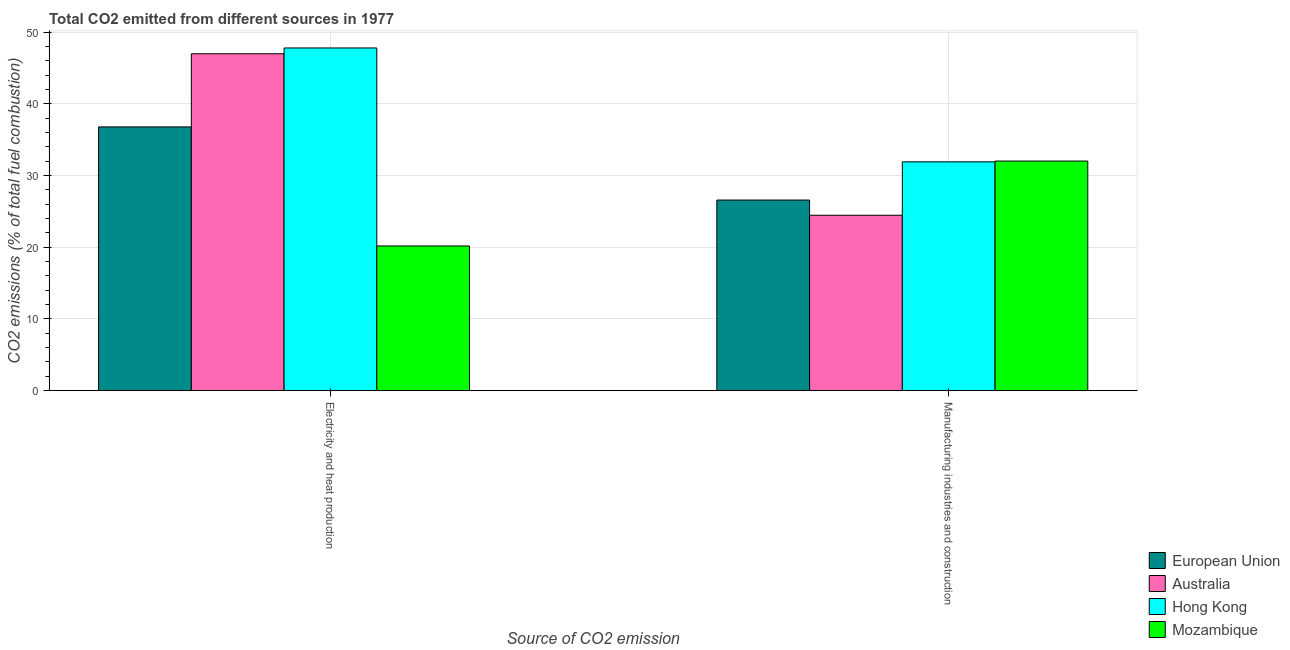How many different coloured bars are there?
Make the answer very short. 4. How many groups of bars are there?
Your answer should be compact. 2. Are the number of bars per tick equal to the number of legend labels?
Make the answer very short. Yes. Are the number of bars on each tick of the X-axis equal?
Your response must be concise. Yes. How many bars are there on the 1st tick from the left?
Offer a very short reply. 4. How many bars are there on the 1st tick from the right?
Your answer should be very brief. 4. What is the label of the 1st group of bars from the left?
Provide a short and direct response. Electricity and heat production. What is the co2 emissions due to manufacturing industries in Mozambique?
Your answer should be compact. 32.02. Across all countries, what is the maximum co2 emissions due to electricity and heat production?
Make the answer very short. 47.79. Across all countries, what is the minimum co2 emissions due to electricity and heat production?
Your answer should be compact. 20.18. In which country was the co2 emissions due to electricity and heat production maximum?
Make the answer very short. Hong Kong. What is the total co2 emissions due to electricity and heat production in the graph?
Your answer should be very brief. 151.73. What is the difference between the co2 emissions due to manufacturing industries in Mozambique and that in Australia?
Your answer should be very brief. 7.56. What is the difference between the co2 emissions due to manufacturing industries in Hong Kong and the co2 emissions due to electricity and heat production in Australia?
Provide a short and direct response. -15.08. What is the average co2 emissions due to manufacturing industries per country?
Give a very brief answer. 28.74. What is the difference between the co2 emissions due to electricity and heat production and co2 emissions due to manufacturing industries in Hong Kong?
Make the answer very short. 15.88. In how many countries, is the co2 emissions due to manufacturing industries greater than 26 %?
Offer a very short reply. 3. What is the ratio of the co2 emissions due to electricity and heat production in Mozambique to that in European Union?
Ensure brevity in your answer.  0.55. What does the 1st bar from the right in Manufacturing industries and construction represents?
Provide a succinct answer. Mozambique. How many bars are there?
Your answer should be very brief. 8. Does the graph contain grids?
Provide a succinct answer. Yes. How are the legend labels stacked?
Offer a terse response. Vertical. What is the title of the graph?
Provide a short and direct response. Total CO2 emitted from different sources in 1977. What is the label or title of the X-axis?
Your response must be concise. Source of CO2 emission. What is the label or title of the Y-axis?
Your answer should be compact. CO2 emissions (% of total fuel combustion). What is the CO2 emissions (% of total fuel combustion) in European Union in Electricity and heat production?
Offer a terse response. 36.78. What is the CO2 emissions (% of total fuel combustion) in Australia in Electricity and heat production?
Provide a short and direct response. 46.98. What is the CO2 emissions (% of total fuel combustion) in Hong Kong in Electricity and heat production?
Provide a short and direct response. 47.79. What is the CO2 emissions (% of total fuel combustion) in Mozambique in Electricity and heat production?
Give a very brief answer. 20.18. What is the CO2 emissions (% of total fuel combustion) of European Union in Manufacturing industries and construction?
Your response must be concise. 26.58. What is the CO2 emissions (% of total fuel combustion) in Australia in Manufacturing industries and construction?
Your response must be concise. 24.46. What is the CO2 emissions (% of total fuel combustion) in Hong Kong in Manufacturing industries and construction?
Provide a succinct answer. 31.91. What is the CO2 emissions (% of total fuel combustion) in Mozambique in Manufacturing industries and construction?
Your answer should be compact. 32.02. Across all Source of CO2 emission, what is the maximum CO2 emissions (% of total fuel combustion) of European Union?
Provide a short and direct response. 36.78. Across all Source of CO2 emission, what is the maximum CO2 emissions (% of total fuel combustion) of Australia?
Offer a terse response. 46.98. Across all Source of CO2 emission, what is the maximum CO2 emissions (% of total fuel combustion) of Hong Kong?
Provide a succinct answer. 47.79. Across all Source of CO2 emission, what is the maximum CO2 emissions (% of total fuel combustion) in Mozambique?
Give a very brief answer. 32.02. Across all Source of CO2 emission, what is the minimum CO2 emissions (% of total fuel combustion) in European Union?
Provide a short and direct response. 26.58. Across all Source of CO2 emission, what is the minimum CO2 emissions (% of total fuel combustion) in Australia?
Offer a very short reply. 24.46. Across all Source of CO2 emission, what is the minimum CO2 emissions (% of total fuel combustion) in Hong Kong?
Offer a very short reply. 31.91. Across all Source of CO2 emission, what is the minimum CO2 emissions (% of total fuel combustion) of Mozambique?
Ensure brevity in your answer.  20.18. What is the total CO2 emissions (% of total fuel combustion) of European Union in the graph?
Your response must be concise. 63.36. What is the total CO2 emissions (% of total fuel combustion) of Australia in the graph?
Ensure brevity in your answer.  71.44. What is the total CO2 emissions (% of total fuel combustion) of Hong Kong in the graph?
Your answer should be compact. 79.7. What is the total CO2 emissions (% of total fuel combustion) in Mozambique in the graph?
Your answer should be very brief. 52.19. What is the difference between the CO2 emissions (% of total fuel combustion) of European Union in Electricity and heat production and that in Manufacturing industries and construction?
Offer a terse response. 10.2. What is the difference between the CO2 emissions (% of total fuel combustion) in Australia in Electricity and heat production and that in Manufacturing industries and construction?
Make the answer very short. 22.52. What is the difference between the CO2 emissions (% of total fuel combustion) in Hong Kong in Electricity and heat production and that in Manufacturing industries and construction?
Keep it short and to the point. 15.88. What is the difference between the CO2 emissions (% of total fuel combustion) of Mozambique in Electricity and heat production and that in Manufacturing industries and construction?
Provide a succinct answer. -11.84. What is the difference between the CO2 emissions (% of total fuel combustion) of European Union in Electricity and heat production and the CO2 emissions (% of total fuel combustion) of Australia in Manufacturing industries and construction?
Provide a short and direct response. 12.32. What is the difference between the CO2 emissions (% of total fuel combustion) in European Union in Electricity and heat production and the CO2 emissions (% of total fuel combustion) in Hong Kong in Manufacturing industries and construction?
Ensure brevity in your answer.  4.87. What is the difference between the CO2 emissions (% of total fuel combustion) in European Union in Electricity and heat production and the CO2 emissions (% of total fuel combustion) in Mozambique in Manufacturing industries and construction?
Ensure brevity in your answer.  4.76. What is the difference between the CO2 emissions (% of total fuel combustion) in Australia in Electricity and heat production and the CO2 emissions (% of total fuel combustion) in Hong Kong in Manufacturing industries and construction?
Offer a very short reply. 15.08. What is the difference between the CO2 emissions (% of total fuel combustion) in Australia in Electricity and heat production and the CO2 emissions (% of total fuel combustion) in Mozambique in Manufacturing industries and construction?
Provide a succinct answer. 14.97. What is the difference between the CO2 emissions (% of total fuel combustion) in Hong Kong in Electricity and heat production and the CO2 emissions (% of total fuel combustion) in Mozambique in Manufacturing industries and construction?
Ensure brevity in your answer.  15.77. What is the average CO2 emissions (% of total fuel combustion) of European Union per Source of CO2 emission?
Provide a succinct answer. 31.68. What is the average CO2 emissions (% of total fuel combustion) in Australia per Source of CO2 emission?
Ensure brevity in your answer.  35.72. What is the average CO2 emissions (% of total fuel combustion) of Hong Kong per Source of CO2 emission?
Your answer should be very brief. 39.85. What is the average CO2 emissions (% of total fuel combustion) in Mozambique per Source of CO2 emission?
Provide a succinct answer. 26.1. What is the difference between the CO2 emissions (% of total fuel combustion) in European Union and CO2 emissions (% of total fuel combustion) in Australia in Electricity and heat production?
Ensure brevity in your answer.  -10.2. What is the difference between the CO2 emissions (% of total fuel combustion) of European Union and CO2 emissions (% of total fuel combustion) of Hong Kong in Electricity and heat production?
Offer a very short reply. -11.01. What is the difference between the CO2 emissions (% of total fuel combustion) of European Union and CO2 emissions (% of total fuel combustion) of Mozambique in Electricity and heat production?
Your response must be concise. 16.6. What is the difference between the CO2 emissions (% of total fuel combustion) in Australia and CO2 emissions (% of total fuel combustion) in Hong Kong in Electricity and heat production?
Ensure brevity in your answer.  -0.81. What is the difference between the CO2 emissions (% of total fuel combustion) of Australia and CO2 emissions (% of total fuel combustion) of Mozambique in Electricity and heat production?
Provide a short and direct response. 26.81. What is the difference between the CO2 emissions (% of total fuel combustion) of Hong Kong and CO2 emissions (% of total fuel combustion) of Mozambique in Electricity and heat production?
Your response must be concise. 27.61. What is the difference between the CO2 emissions (% of total fuel combustion) in European Union and CO2 emissions (% of total fuel combustion) in Australia in Manufacturing industries and construction?
Provide a succinct answer. 2.12. What is the difference between the CO2 emissions (% of total fuel combustion) of European Union and CO2 emissions (% of total fuel combustion) of Hong Kong in Manufacturing industries and construction?
Give a very brief answer. -5.33. What is the difference between the CO2 emissions (% of total fuel combustion) of European Union and CO2 emissions (% of total fuel combustion) of Mozambique in Manufacturing industries and construction?
Give a very brief answer. -5.44. What is the difference between the CO2 emissions (% of total fuel combustion) of Australia and CO2 emissions (% of total fuel combustion) of Hong Kong in Manufacturing industries and construction?
Keep it short and to the point. -7.45. What is the difference between the CO2 emissions (% of total fuel combustion) in Australia and CO2 emissions (% of total fuel combustion) in Mozambique in Manufacturing industries and construction?
Offer a terse response. -7.56. What is the difference between the CO2 emissions (% of total fuel combustion) of Hong Kong and CO2 emissions (% of total fuel combustion) of Mozambique in Manufacturing industries and construction?
Provide a short and direct response. -0.11. What is the ratio of the CO2 emissions (% of total fuel combustion) in European Union in Electricity and heat production to that in Manufacturing industries and construction?
Your response must be concise. 1.38. What is the ratio of the CO2 emissions (% of total fuel combustion) of Australia in Electricity and heat production to that in Manufacturing industries and construction?
Give a very brief answer. 1.92. What is the ratio of the CO2 emissions (% of total fuel combustion) in Hong Kong in Electricity and heat production to that in Manufacturing industries and construction?
Your response must be concise. 1.5. What is the ratio of the CO2 emissions (% of total fuel combustion) in Mozambique in Electricity and heat production to that in Manufacturing industries and construction?
Provide a short and direct response. 0.63. What is the difference between the highest and the second highest CO2 emissions (% of total fuel combustion) in European Union?
Provide a succinct answer. 10.2. What is the difference between the highest and the second highest CO2 emissions (% of total fuel combustion) of Australia?
Provide a succinct answer. 22.52. What is the difference between the highest and the second highest CO2 emissions (% of total fuel combustion) in Hong Kong?
Offer a terse response. 15.88. What is the difference between the highest and the second highest CO2 emissions (% of total fuel combustion) of Mozambique?
Provide a short and direct response. 11.84. What is the difference between the highest and the lowest CO2 emissions (% of total fuel combustion) of European Union?
Provide a succinct answer. 10.2. What is the difference between the highest and the lowest CO2 emissions (% of total fuel combustion) of Australia?
Keep it short and to the point. 22.52. What is the difference between the highest and the lowest CO2 emissions (% of total fuel combustion) in Hong Kong?
Offer a terse response. 15.88. What is the difference between the highest and the lowest CO2 emissions (% of total fuel combustion) in Mozambique?
Your response must be concise. 11.84. 